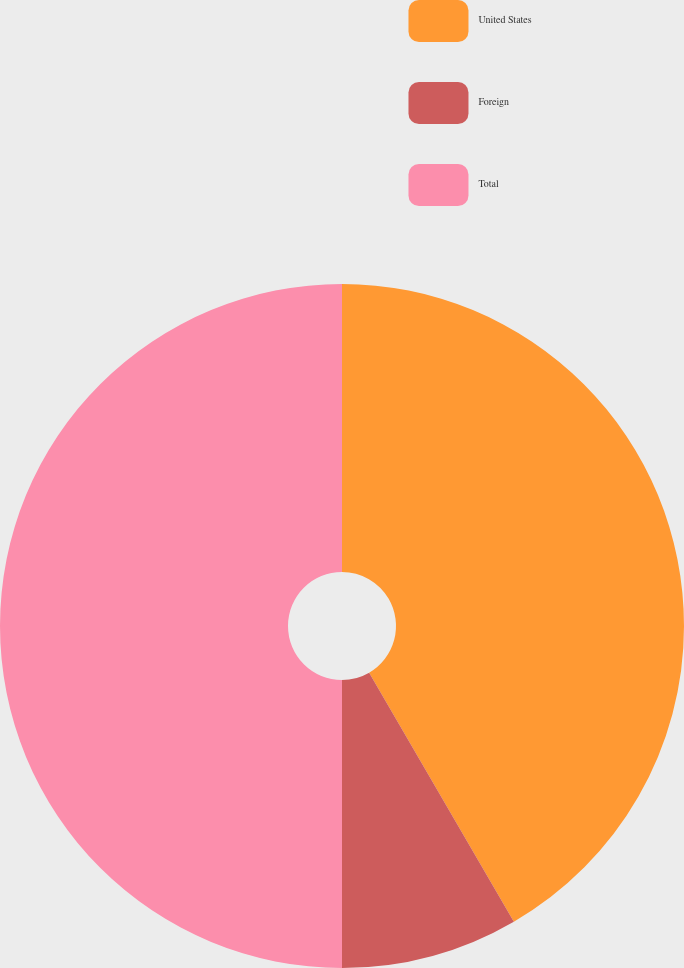<chart> <loc_0><loc_0><loc_500><loc_500><pie_chart><fcel>United States<fcel>Foreign<fcel>Total<nl><fcel>41.62%<fcel>8.38%<fcel>50.0%<nl></chart> 